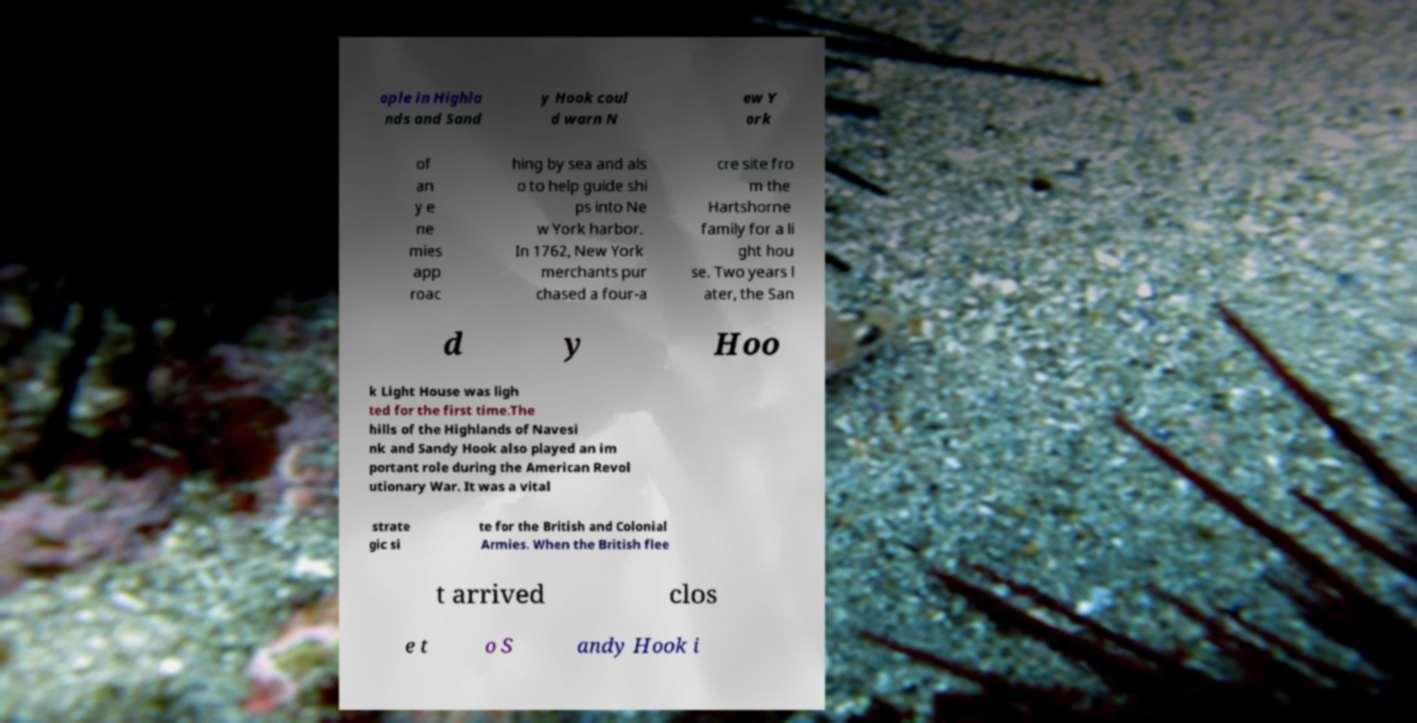What messages or text are displayed in this image? I need them in a readable, typed format. ople in Highla nds and Sand y Hook coul d warn N ew Y ork of an y e ne mies app roac hing by sea and als o to help guide shi ps into Ne w York harbor. In 1762, New York merchants pur chased a four-a cre site fro m the Hartshorne family for a li ght hou se. Two years l ater, the San d y Hoo k Light House was ligh ted for the first time.The hills of the Highlands of Navesi nk and Sandy Hook also played an im portant role during the American Revol utionary War. It was a vital strate gic si te for the British and Colonial Armies. When the British flee t arrived clos e t o S andy Hook i 